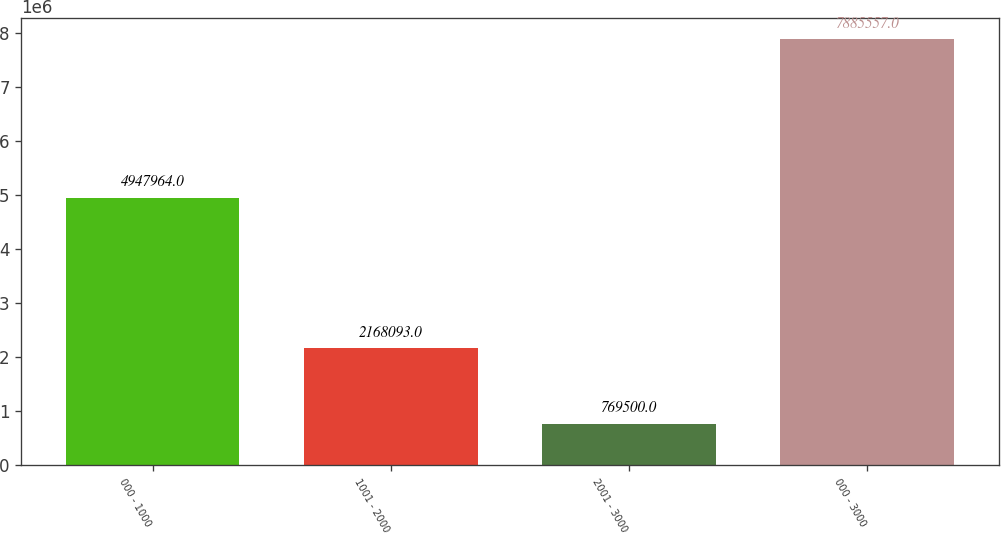<chart> <loc_0><loc_0><loc_500><loc_500><bar_chart><fcel>000 - 1000<fcel>1001 - 2000<fcel>2001 - 3000<fcel>000 - 3000<nl><fcel>4.94796e+06<fcel>2.16809e+06<fcel>769500<fcel>7.88556e+06<nl></chart> 